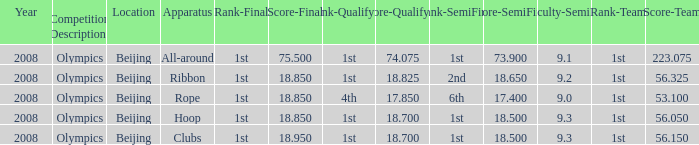On which apparatus did Kanayeva have a final score smaller than 75.5 and a qualifying score smaller than 18.7? Rope. 